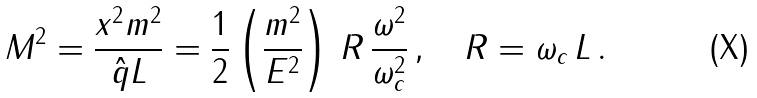<formula> <loc_0><loc_0><loc_500><loc_500>M ^ { 2 } = \frac { x ^ { 2 } m ^ { 2 } } { \hat { q } L } = \frac { 1 } { 2 } \left ( \frac { m ^ { 2 } } { E ^ { 2 } } \right ) \, R \, \frac { \omega ^ { 2 } } { \omega _ { c } ^ { 2 } } \, , \quad R = \omega _ { c } \, L \, .</formula> 